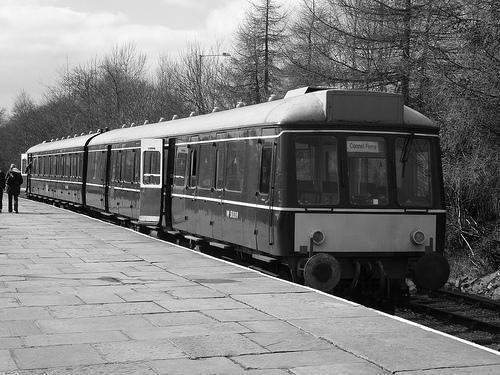How many cars on train?
Give a very brief answer. 2. 